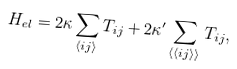<formula> <loc_0><loc_0><loc_500><loc_500>H _ { e l } = 2 \kappa \sum _ { \langle i j \rangle } T _ { i j } + 2 \kappa ^ { \prime } \sum _ { \langle \langle { i j } \rangle \rangle } T _ { i j } ,</formula> 